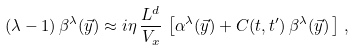<formula> <loc_0><loc_0><loc_500><loc_500>( \lambda - 1 ) \, \beta ^ { \lambda } ( \vec { y } ) \approx i \eta \, \frac { L ^ { d } } { V _ { x } } \, \left [ \alpha ^ { \lambda } ( \vec { y } ) + C ( t , t ^ { \prime } ) \, \beta ^ { \lambda } ( \vec { y } ) \, \right ] \, ,</formula> 